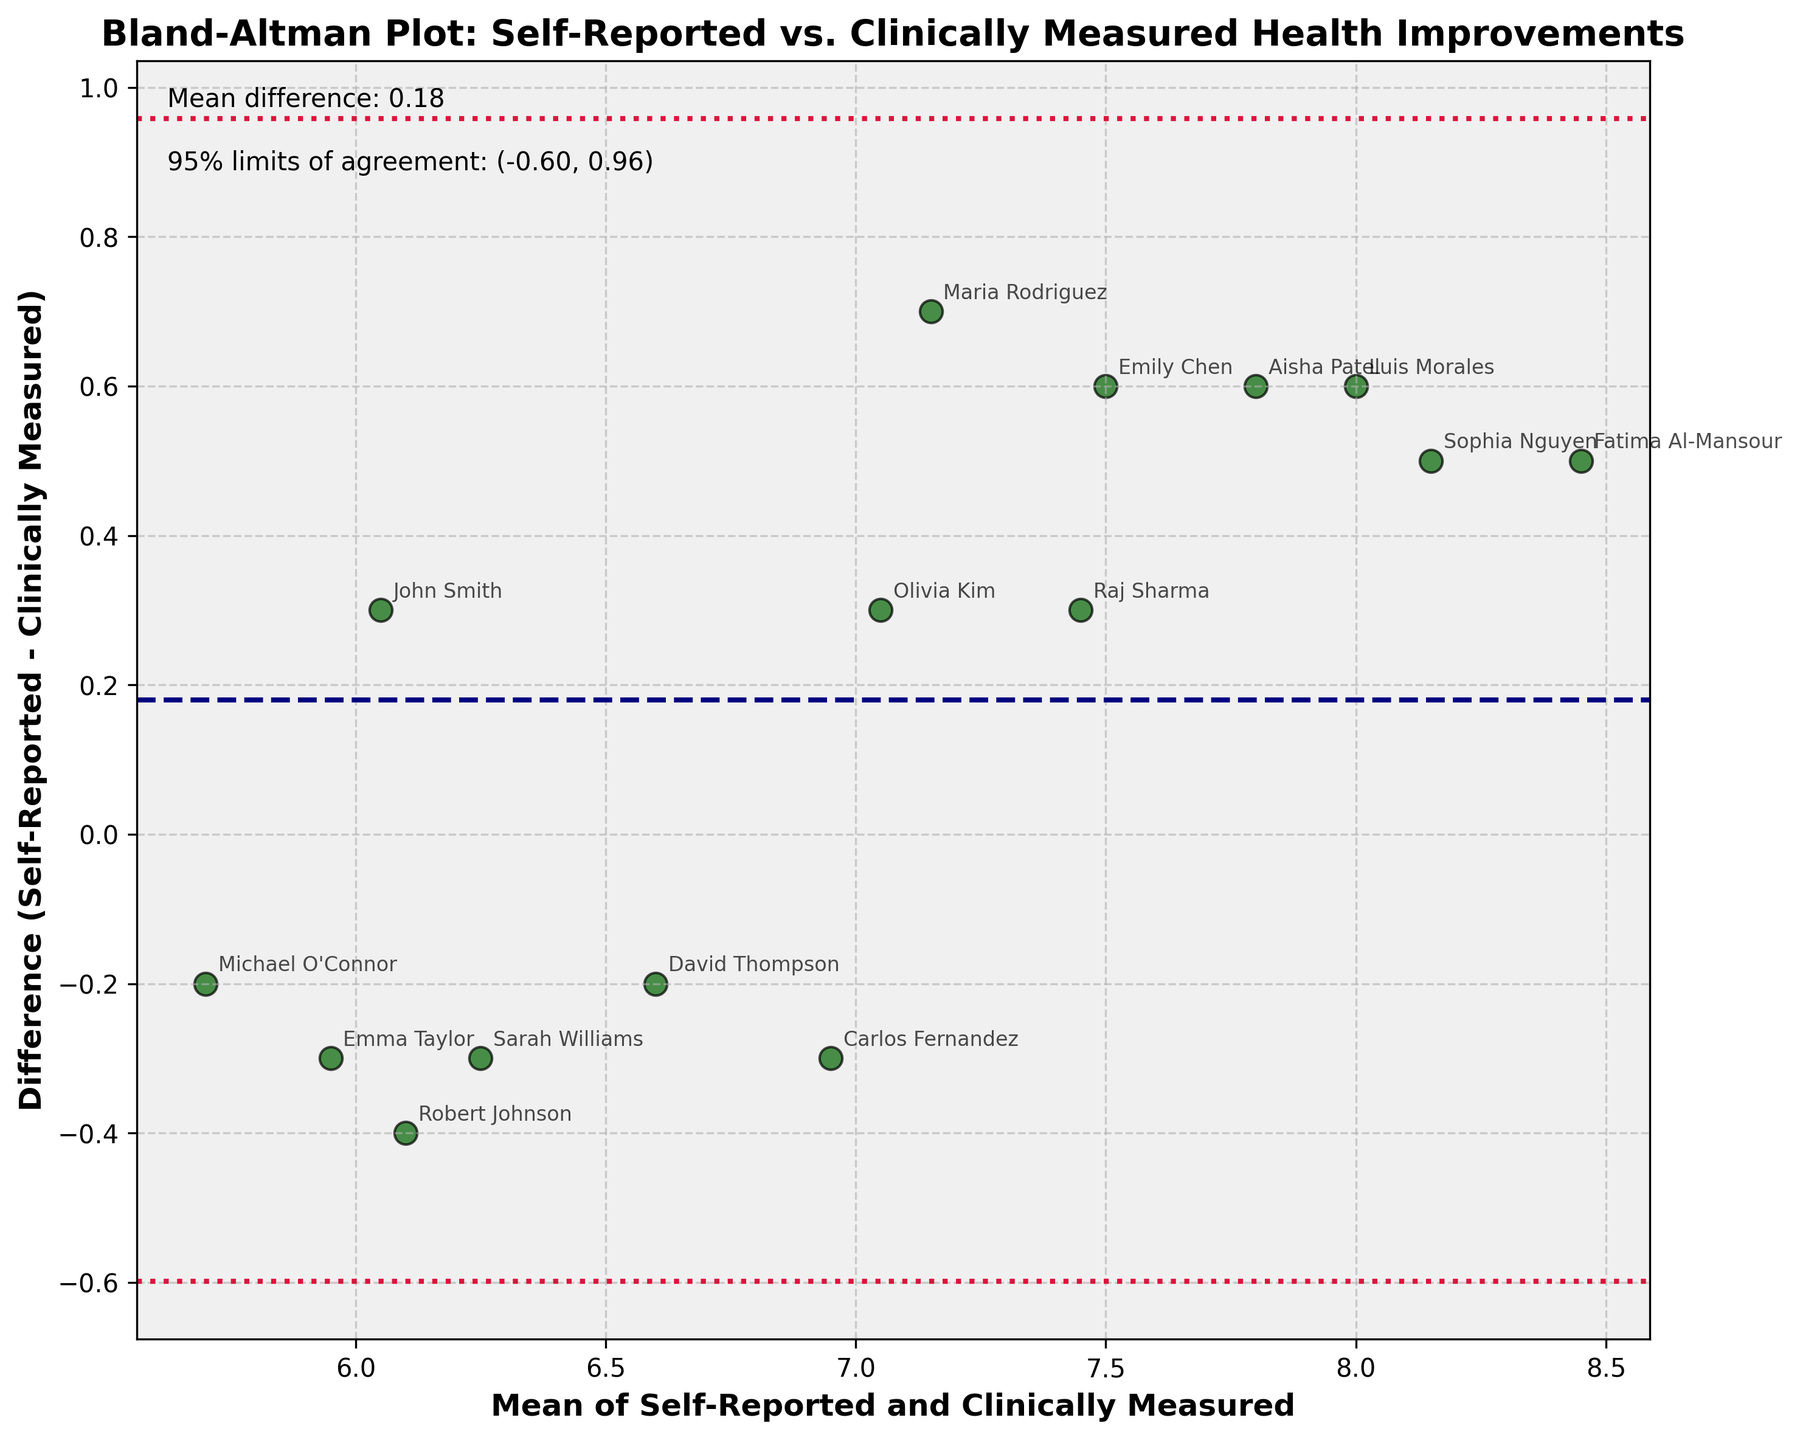What is the title of the plot? The title is located at the top center of the plot. It provides context for what the plot is about.
Answer: Bland-Altman Plot: Self-Reported vs. Clinically Measured Health Improvements How many data points are shown in the plot? Count the number of scatter points on the plot to find the total number of data points.
Answer: 15 What do the green scatter points represent in the plot? Each green scatter point represents a participant's mean of self-reported and clinically measured health improvement plotted against the difference between self-reported and clinically measured health improvement.
Answer: Participants' health improvement values What is the mean difference between self-reported and clinically measured health improvements? The mean difference is marked by a dashed line and its value is provided as a text annotation on the plot.
Answer: 0.24 What are the 95% limits of agreement for the differences between self-reported and clinically measured health improvements? The 95% limits of agreement are shown as dotted lines above and below the mean difference line, and the values are provided as a text annotation on the plot.
Answer: (-0.80, 1.28) Who is the participant with the highest mean value of health improvements? Look for the highest point on the x-axis (mean). Check the annotation next to this point to identify the participant.
Answer: Fatima Al-Mansour Which participant has the largest positive difference between self-reported and clinically measured health improvements? Identify the scatter point that is highest on the y-axis (difference). Check the annotation next to this point to identify the participant.
Answer: Maria Rodriguez Which participant has the largest negative difference between self-reported and clinically measured health improvements? Identify the scatter point that is the lowest on the y-axis (difference). Check the annotation next to this point to identify the participant.
Answer: Robert Johnson Is the mean of the differences above or below zero? The mean of the differences is indicated by the horizontal dashed line. If it is above the x-axis line (zero difference), then it is above zero.
Answer: Above zero 